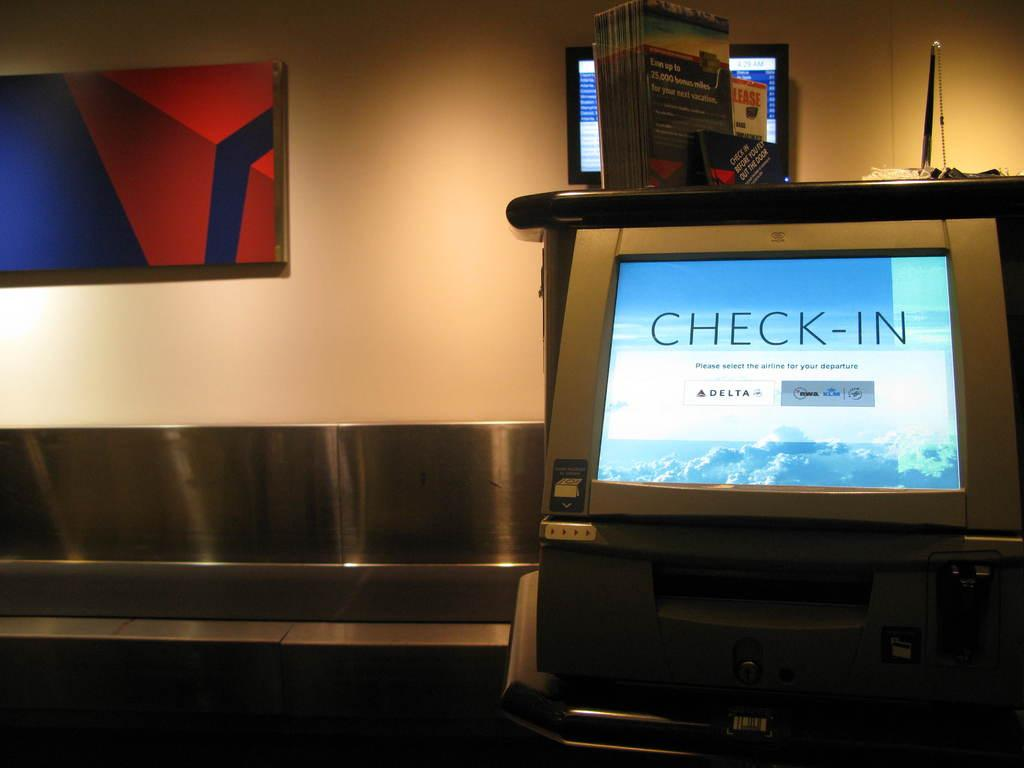<image>
Summarize the visual content of the image. A check in computer at an airport in front of a silver device. 